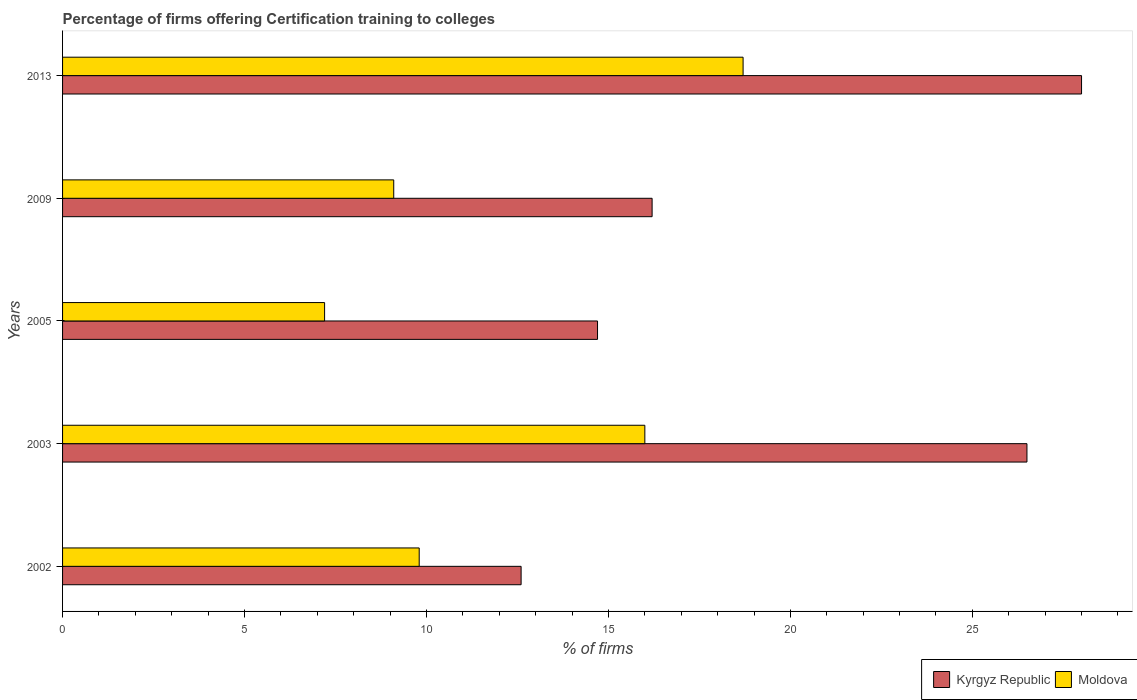Are the number of bars per tick equal to the number of legend labels?
Provide a short and direct response. Yes. How many bars are there on the 4th tick from the top?
Keep it short and to the point. 2. What is the label of the 1st group of bars from the top?
Your response must be concise. 2013. What is the percentage of firms offering certification training to colleges in Kyrgyz Republic in 2009?
Make the answer very short. 16.2. Across all years, what is the maximum percentage of firms offering certification training to colleges in Moldova?
Your answer should be very brief. 18.7. In which year was the percentage of firms offering certification training to colleges in Moldova minimum?
Your response must be concise. 2005. What is the total percentage of firms offering certification training to colleges in Moldova in the graph?
Your answer should be compact. 60.8. What is the difference between the percentage of firms offering certification training to colleges in Kyrgyz Republic in 2002 and that in 2013?
Your answer should be very brief. -15.4. What is the difference between the percentage of firms offering certification training to colleges in Moldova in 2005 and the percentage of firms offering certification training to colleges in Kyrgyz Republic in 2009?
Provide a short and direct response. -9. What is the average percentage of firms offering certification training to colleges in Kyrgyz Republic per year?
Make the answer very short. 19.6. In the year 2005, what is the difference between the percentage of firms offering certification training to colleges in Moldova and percentage of firms offering certification training to colleges in Kyrgyz Republic?
Offer a terse response. -7.5. What is the ratio of the percentage of firms offering certification training to colleges in Moldova in 2009 to that in 2013?
Give a very brief answer. 0.49. Is the percentage of firms offering certification training to colleges in Kyrgyz Republic in 2002 less than that in 2005?
Your answer should be very brief. Yes. What is the difference between the highest and the second highest percentage of firms offering certification training to colleges in Kyrgyz Republic?
Ensure brevity in your answer.  1.5. What does the 2nd bar from the top in 2002 represents?
Offer a very short reply. Kyrgyz Republic. What does the 2nd bar from the bottom in 2002 represents?
Your response must be concise. Moldova. How many years are there in the graph?
Offer a terse response. 5. What is the difference between two consecutive major ticks on the X-axis?
Your response must be concise. 5. Are the values on the major ticks of X-axis written in scientific E-notation?
Offer a terse response. No. What is the title of the graph?
Offer a terse response. Percentage of firms offering Certification training to colleges. Does "Lebanon" appear as one of the legend labels in the graph?
Offer a very short reply. No. What is the label or title of the X-axis?
Provide a short and direct response. % of firms. What is the % of firms in Kyrgyz Republic in 2003?
Offer a terse response. 26.5. What is the % of firms of Moldova in 2003?
Your answer should be compact. 16. What is the % of firms of Moldova in 2005?
Your response must be concise. 7.2. What is the % of firms of Kyrgyz Republic in 2009?
Your answer should be compact. 16.2. What is the % of firms in Kyrgyz Republic in 2013?
Your answer should be compact. 28. Across all years, what is the maximum % of firms in Kyrgyz Republic?
Make the answer very short. 28. Across all years, what is the minimum % of firms of Moldova?
Give a very brief answer. 7.2. What is the total % of firms in Moldova in the graph?
Offer a very short reply. 60.8. What is the difference between the % of firms of Kyrgyz Republic in 2002 and that in 2003?
Your answer should be compact. -13.9. What is the difference between the % of firms in Moldova in 2002 and that in 2003?
Give a very brief answer. -6.2. What is the difference between the % of firms in Moldova in 2002 and that in 2005?
Provide a succinct answer. 2.6. What is the difference between the % of firms of Kyrgyz Republic in 2002 and that in 2009?
Your answer should be compact. -3.6. What is the difference between the % of firms of Moldova in 2002 and that in 2009?
Your answer should be compact. 0.7. What is the difference between the % of firms in Kyrgyz Republic in 2002 and that in 2013?
Make the answer very short. -15.4. What is the difference between the % of firms in Moldova in 2002 and that in 2013?
Ensure brevity in your answer.  -8.9. What is the difference between the % of firms of Kyrgyz Republic in 2003 and that in 2005?
Offer a very short reply. 11.8. What is the difference between the % of firms in Kyrgyz Republic in 2003 and that in 2009?
Ensure brevity in your answer.  10.3. What is the difference between the % of firms in Moldova in 2003 and that in 2013?
Make the answer very short. -2.7. What is the difference between the % of firms in Moldova in 2005 and that in 2009?
Keep it short and to the point. -1.9. What is the difference between the % of firms in Kyrgyz Republic in 2002 and the % of firms in Moldova in 2003?
Offer a very short reply. -3.4. What is the difference between the % of firms in Kyrgyz Republic in 2002 and the % of firms in Moldova in 2005?
Make the answer very short. 5.4. What is the difference between the % of firms in Kyrgyz Republic in 2003 and the % of firms in Moldova in 2005?
Your answer should be very brief. 19.3. What is the difference between the % of firms of Kyrgyz Republic in 2003 and the % of firms of Moldova in 2009?
Give a very brief answer. 17.4. What is the difference between the % of firms of Kyrgyz Republic in 2003 and the % of firms of Moldova in 2013?
Offer a terse response. 7.8. What is the difference between the % of firms in Kyrgyz Republic in 2005 and the % of firms in Moldova in 2009?
Offer a very short reply. 5.6. What is the difference between the % of firms in Kyrgyz Republic in 2009 and the % of firms in Moldova in 2013?
Give a very brief answer. -2.5. What is the average % of firms of Kyrgyz Republic per year?
Provide a short and direct response. 19.6. What is the average % of firms in Moldova per year?
Your answer should be very brief. 12.16. In the year 2002, what is the difference between the % of firms of Kyrgyz Republic and % of firms of Moldova?
Your response must be concise. 2.8. In the year 2003, what is the difference between the % of firms of Kyrgyz Republic and % of firms of Moldova?
Give a very brief answer. 10.5. In the year 2009, what is the difference between the % of firms of Kyrgyz Republic and % of firms of Moldova?
Provide a short and direct response. 7.1. What is the ratio of the % of firms of Kyrgyz Republic in 2002 to that in 2003?
Your answer should be very brief. 0.48. What is the ratio of the % of firms of Moldova in 2002 to that in 2003?
Offer a very short reply. 0.61. What is the ratio of the % of firms in Moldova in 2002 to that in 2005?
Provide a succinct answer. 1.36. What is the ratio of the % of firms in Kyrgyz Republic in 2002 to that in 2013?
Your answer should be very brief. 0.45. What is the ratio of the % of firms in Moldova in 2002 to that in 2013?
Provide a short and direct response. 0.52. What is the ratio of the % of firms of Kyrgyz Republic in 2003 to that in 2005?
Provide a succinct answer. 1.8. What is the ratio of the % of firms of Moldova in 2003 to that in 2005?
Your answer should be very brief. 2.22. What is the ratio of the % of firms in Kyrgyz Republic in 2003 to that in 2009?
Offer a very short reply. 1.64. What is the ratio of the % of firms of Moldova in 2003 to that in 2009?
Give a very brief answer. 1.76. What is the ratio of the % of firms of Kyrgyz Republic in 2003 to that in 2013?
Offer a very short reply. 0.95. What is the ratio of the % of firms of Moldova in 2003 to that in 2013?
Keep it short and to the point. 0.86. What is the ratio of the % of firms in Kyrgyz Republic in 2005 to that in 2009?
Keep it short and to the point. 0.91. What is the ratio of the % of firms of Moldova in 2005 to that in 2009?
Ensure brevity in your answer.  0.79. What is the ratio of the % of firms of Kyrgyz Republic in 2005 to that in 2013?
Make the answer very short. 0.53. What is the ratio of the % of firms in Moldova in 2005 to that in 2013?
Ensure brevity in your answer.  0.39. What is the ratio of the % of firms of Kyrgyz Republic in 2009 to that in 2013?
Your answer should be compact. 0.58. What is the ratio of the % of firms of Moldova in 2009 to that in 2013?
Give a very brief answer. 0.49. What is the difference between the highest and the second highest % of firms of Moldova?
Your answer should be compact. 2.7. 